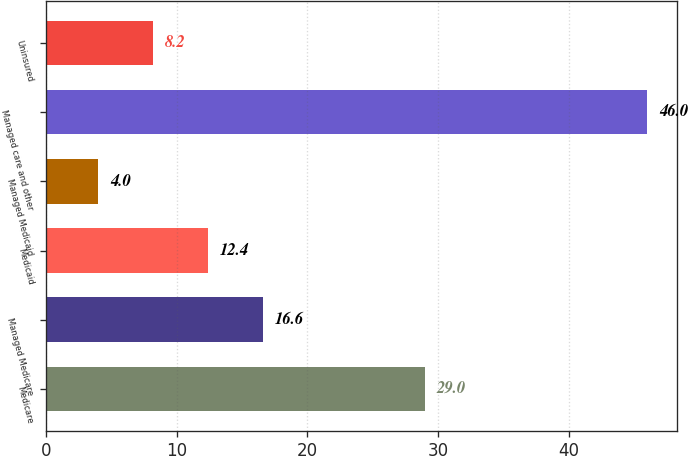Convert chart. <chart><loc_0><loc_0><loc_500><loc_500><bar_chart><fcel>Medicare<fcel>Managed Medicare<fcel>Medicaid<fcel>Managed Medicaid<fcel>Managed care and other<fcel>Uninsured<nl><fcel>29<fcel>16.6<fcel>12.4<fcel>4<fcel>46<fcel>8.2<nl></chart> 